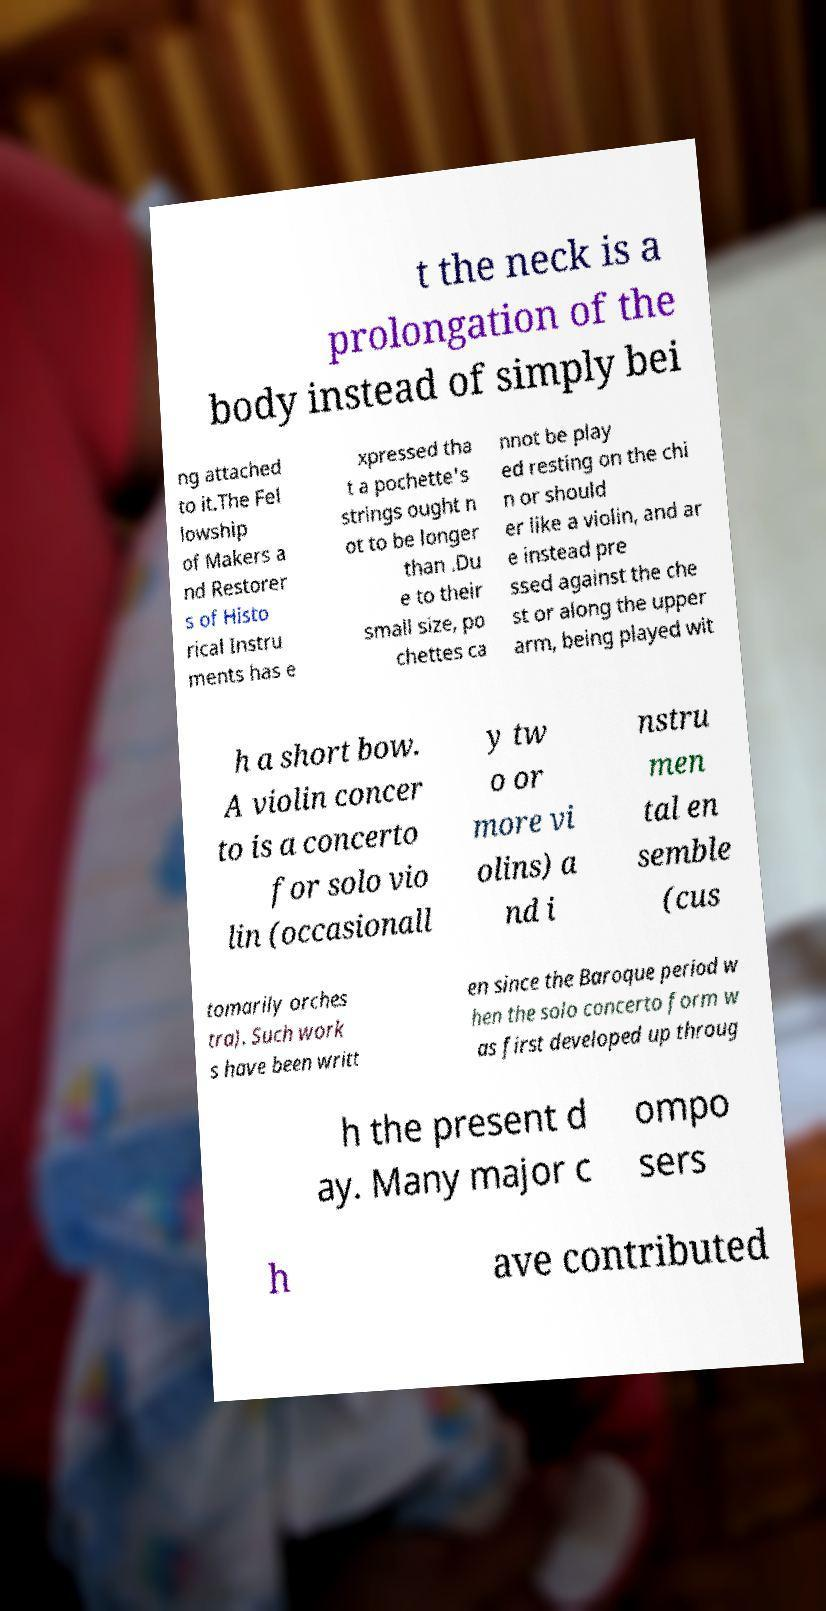Could you extract and type out the text from this image? t the neck is a prolongation of the body instead of simply bei ng attached to it.The Fel lowship of Makers a nd Restorer s of Histo rical Instru ments has e xpressed tha t a pochette's strings ought n ot to be longer than .Du e to their small size, po chettes ca nnot be play ed resting on the chi n or should er like a violin, and ar e instead pre ssed against the che st or along the upper arm, being played wit h a short bow. A violin concer to is a concerto for solo vio lin (occasionall y tw o or more vi olins) a nd i nstru men tal en semble (cus tomarily orches tra). Such work s have been writt en since the Baroque period w hen the solo concerto form w as first developed up throug h the present d ay. Many major c ompo sers h ave contributed 